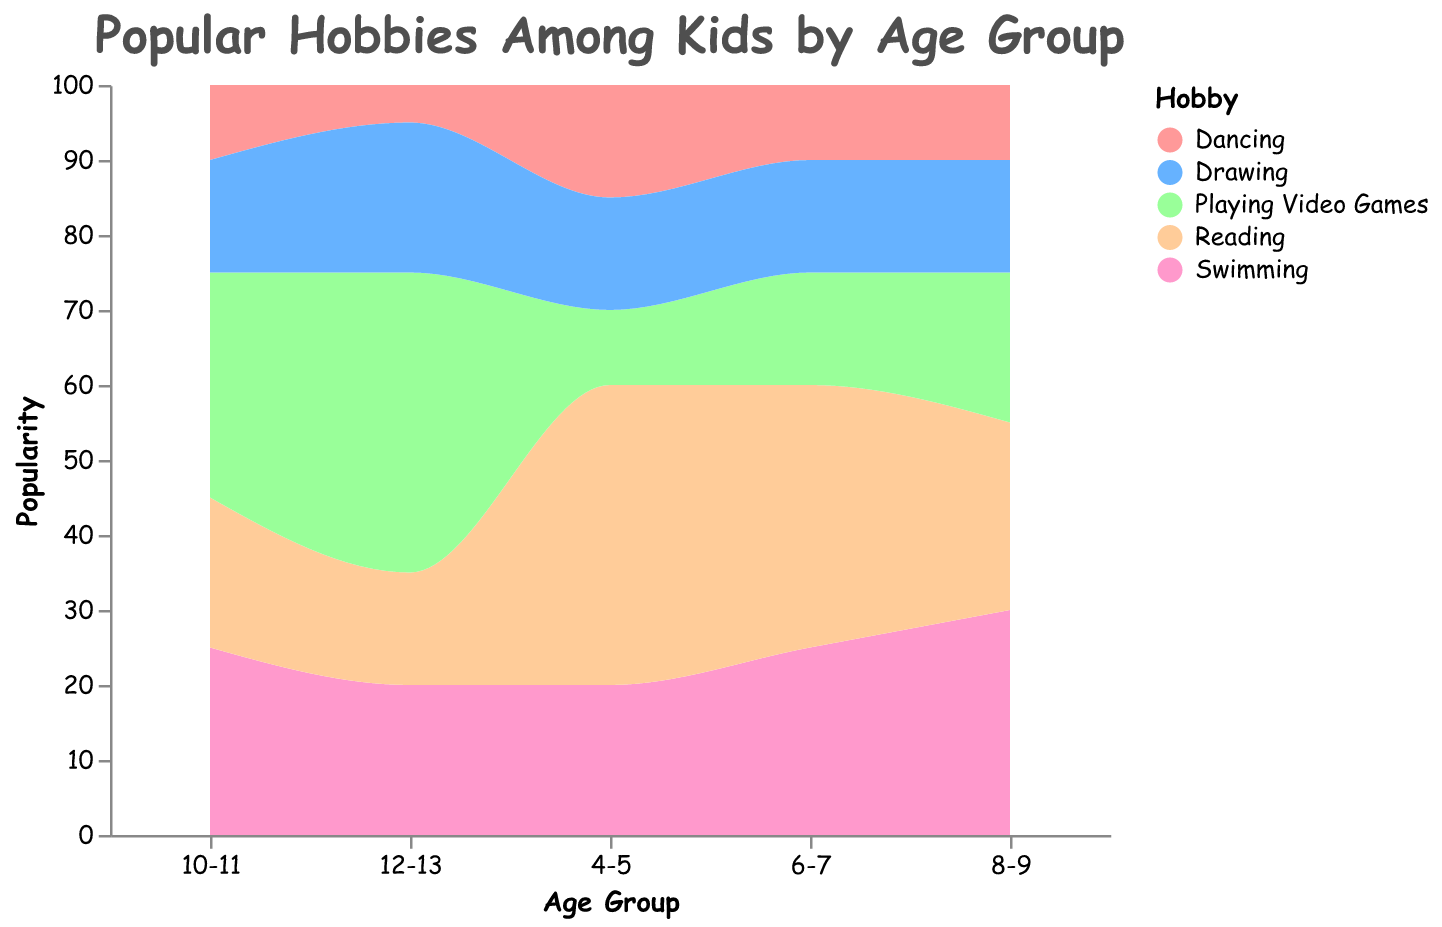What is the title of the figure? The title is usually found at the top or above the visual representation in a larger or more prominent font size. It summarizes what the figure is about.
Answer: Popular Hobbies Among Kids by Age Group Which age group has the most interest in reading? By observing the color assigned to 'Reading' and identifying the group with the highest area amount for that color along the y-axis, we can determine the age group with the most interest.
Answer: 4-5 Which hobby is the most popular among kids aged 12-13? Looking at the stacked areas for the '12-13' age group, identify which color has the largest vertical space (y-axis value), which represents the most popular hobby.
Answer: Playing Video Games How does the popularity of swimming change from age group 4-5 to 12-13? By tracing the 'Swimming' area from age group 4-5 through to 12-13, you can observe its trend, whether it is increasing, decreasing, or remaining constant.
Answer: Decreases Comparing 'Reading' and 'Drawing', which hobby has more popularity in the age group 6-7? Compare the y-axis values (vertical space) for 'Reading' and 'Drawing' in the age group 6-7 to see which has a higher value.
Answer: Reading What's the least popular hobby for every age group? For each age group, identify the hobby with the smallest vertical space (y-axis value) by examining the different colored areas.
Answer: 4-5: Playing Video Games; 6-7: Dancing; 8-9: Dancing; 10-11: Dancing; 12-13: Dancing Which age group shows a peak in popularity for playing video games? Trace the 'Playing Video Games' area across the age groups and find the age group with the highest value.
Answer: 12-13 What is the sum of the popularity values of swimming and drawing for age group 8-9? Locate the values for 'Swimming' and 'Drawing' under age group '8-9' and add them together. 30 (Swimming) + 15 (Drawing)
Answer: 45 Is dancing more popular than drawing in any age group? Compare the y-axis values of 'Dancing' and 'Drawing' across all age groups to see if 'Dancing' exceeds 'Drawing' in any.
Answer: No How does the popularity of reading change as kids grow from age group 4-5 to 12-13? Track the 'Reading' area's trend lengthwise from the smallest to the largest age group. This will show either an increase or decrease in y-axis values over time.
Answer: Decreases 